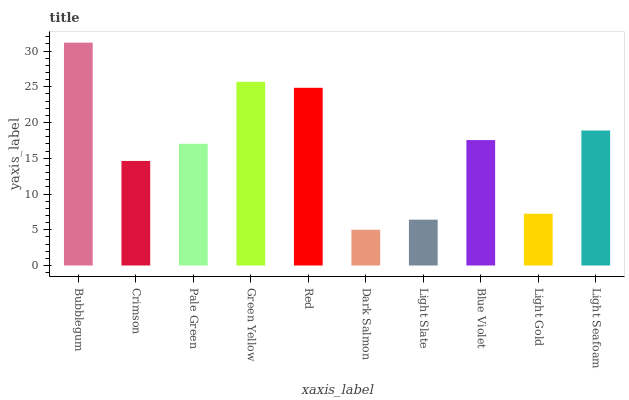Is Crimson the minimum?
Answer yes or no. No. Is Crimson the maximum?
Answer yes or no. No. Is Bubblegum greater than Crimson?
Answer yes or no. Yes. Is Crimson less than Bubblegum?
Answer yes or no. Yes. Is Crimson greater than Bubblegum?
Answer yes or no. No. Is Bubblegum less than Crimson?
Answer yes or no. No. Is Blue Violet the high median?
Answer yes or no. Yes. Is Pale Green the low median?
Answer yes or no. Yes. Is Light Seafoam the high median?
Answer yes or no. No. Is Light Slate the low median?
Answer yes or no. No. 